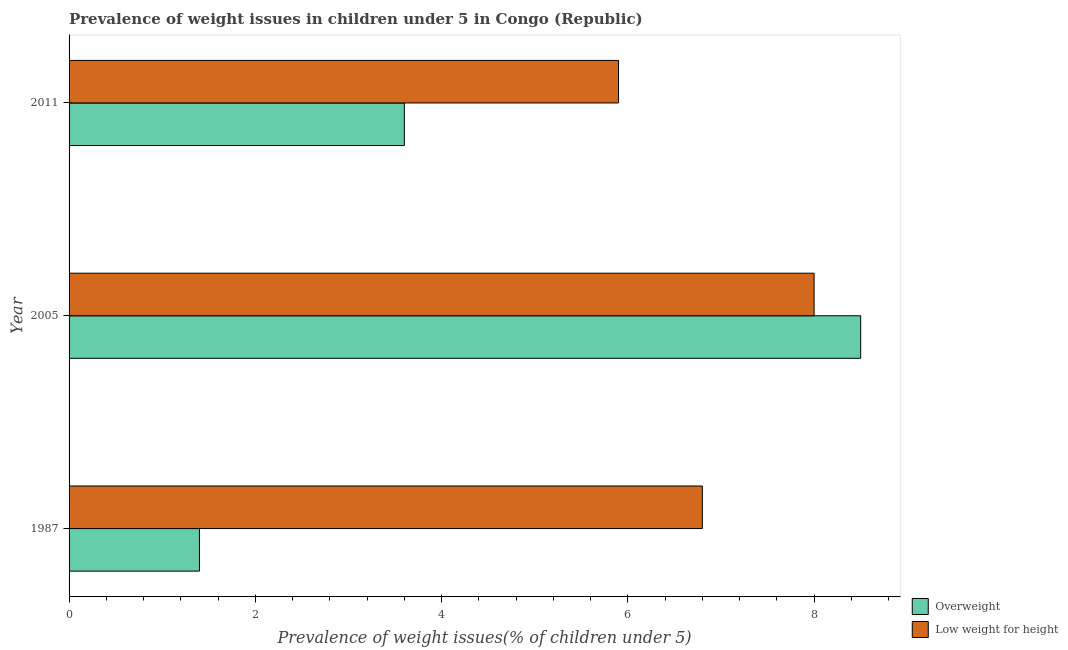How many different coloured bars are there?
Offer a very short reply. 2. How many groups of bars are there?
Your answer should be compact. 3. How many bars are there on the 2nd tick from the bottom?
Provide a short and direct response. 2. What is the label of the 2nd group of bars from the top?
Keep it short and to the point. 2005. In how many cases, is the number of bars for a given year not equal to the number of legend labels?
Offer a terse response. 0. What is the percentage of overweight children in 2005?
Your answer should be compact. 8.5. Across all years, what is the minimum percentage of overweight children?
Keep it short and to the point. 1.4. In which year was the percentage of overweight children maximum?
Your answer should be very brief. 2005. What is the total percentage of overweight children in the graph?
Provide a succinct answer. 13.5. What is the difference between the percentage of overweight children in 2005 and the percentage of underweight children in 1987?
Make the answer very short. 1.7. What is the ratio of the percentage of underweight children in 2005 to that in 2011?
Make the answer very short. 1.36. In how many years, is the percentage of underweight children greater than the average percentage of underweight children taken over all years?
Give a very brief answer. 1. What does the 2nd bar from the top in 2005 represents?
Your answer should be very brief. Overweight. What does the 1st bar from the bottom in 1987 represents?
Ensure brevity in your answer.  Overweight. How many bars are there?
Your answer should be compact. 6. How many years are there in the graph?
Ensure brevity in your answer.  3. What is the difference between two consecutive major ticks on the X-axis?
Your answer should be very brief. 2. Are the values on the major ticks of X-axis written in scientific E-notation?
Make the answer very short. No. Does the graph contain any zero values?
Provide a short and direct response. No. Does the graph contain grids?
Provide a succinct answer. No. Where does the legend appear in the graph?
Your answer should be compact. Bottom right. How many legend labels are there?
Your response must be concise. 2. What is the title of the graph?
Ensure brevity in your answer.  Prevalence of weight issues in children under 5 in Congo (Republic). Does "All education staff compensation" appear as one of the legend labels in the graph?
Provide a succinct answer. No. What is the label or title of the X-axis?
Your response must be concise. Prevalence of weight issues(% of children under 5). What is the label or title of the Y-axis?
Ensure brevity in your answer.  Year. What is the Prevalence of weight issues(% of children under 5) in Overweight in 1987?
Offer a terse response. 1.4. What is the Prevalence of weight issues(% of children under 5) in Low weight for height in 1987?
Offer a very short reply. 6.8. What is the Prevalence of weight issues(% of children under 5) in Overweight in 2011?
Ensure brevity in your answer.  3.6. What is the Prevalence of weight issues(% of children under 5) of Low weight for height in 2011?
Provide a short and direct response. 5.9. Across all years, what is the minimum Prevalence of weight issues(% of children under 5) in Overweight?
Your answer should be very brief. 1.4. Across all years, what is the minimum Prevalence of weight issues(% of children under 5) of Low weight for height?
Your answer should be compact. 5.9. What is the total Prevalence of weight issues(% of children under 5) of Low weight for height in the graph?
Ensure brevity in your answer.  20.7. What is the difference between the Prevalence of weight issues(% of children under 5) in Low weight for height in 1987 and that in 2011?
Keep it short and to the point. 0.9. What is the difference between the Prevalence of weight issues(% of children under 5) of Overweight in 2005 and that in 2011?
Your answer should be very brief. 4.9. What is the difference between the Prevalence of weight issues(% of children under 5) in Overweight in 1987 and the Prevalence of weight issues(% of children under 5) in Low weight for height in 2011?
Provide a short and direct response. -4.5. What is the average Prevalence of weight issues(% of children under 5) of Low weight for height per year?
Give a very brief answer. 6.9. What is the ratio of the Prevalence of weight issues(% of children under 5) of Overweight in 1987 to that in 2005?
Offer a very short reply. 0.16. What is the ratio of the Prevalence of weight issues(% of children under 5) in Low weight for height in 1987 to that in 2005?
Your answer should be very brief. 0.85. What is the ratio of the Prevalence of weight issues(% of children under 5) of Overweight in 1987 to that in 2011?
Offer a very short reply. 0.39. What is the ratio of the Prevalence of weight issues(% of children under 5) of Low weight for height in 1987 to that in 2011?
Ensure brevity in your answer.  1.15. What is the ratio of the Prevalence of weight issues(% of children under 5) of Overweight in 2005 to that in 2011?
Ensure brevity in your answer.  2.36. What is the ratio of the Prevalence of weight issues(% of children under 5) of Low weight for height in 2005 to that in 2011?
Give a very brief answer. 1.36. What is the difference between the highest and the second highest Prevalence of weight issues(% of children under 5) in Low weight for height?
Your answer should be compact. 1.2. 